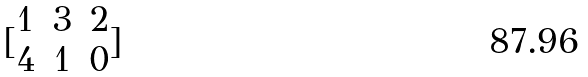<formula> <loc_0><loc_0><loc_500><loc_500>[ \begin{matrix} 1 & 3 & 2 \\ 4 & 1 & 0 \end{matrix} ]</formula> 